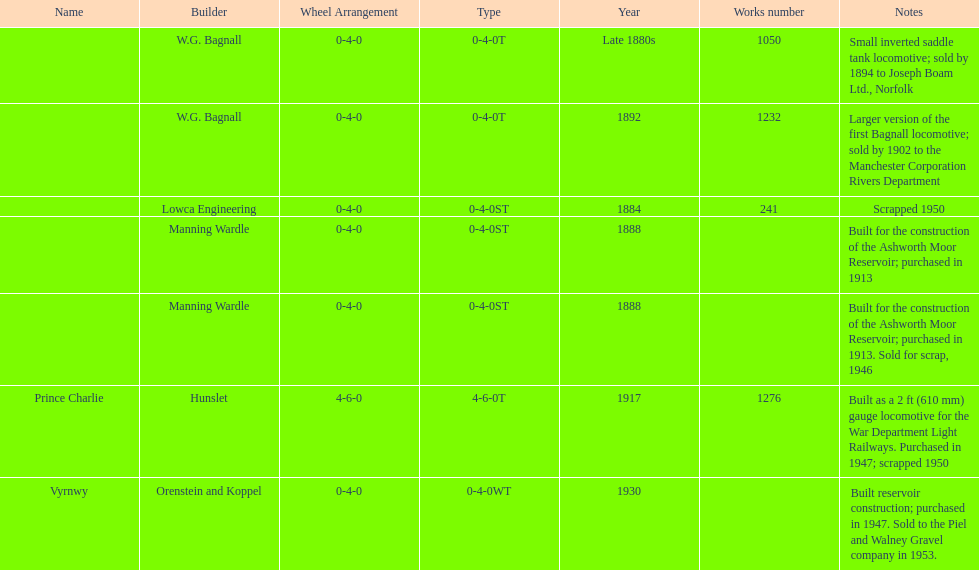How many locomotives were built before the 1900s? 5. 